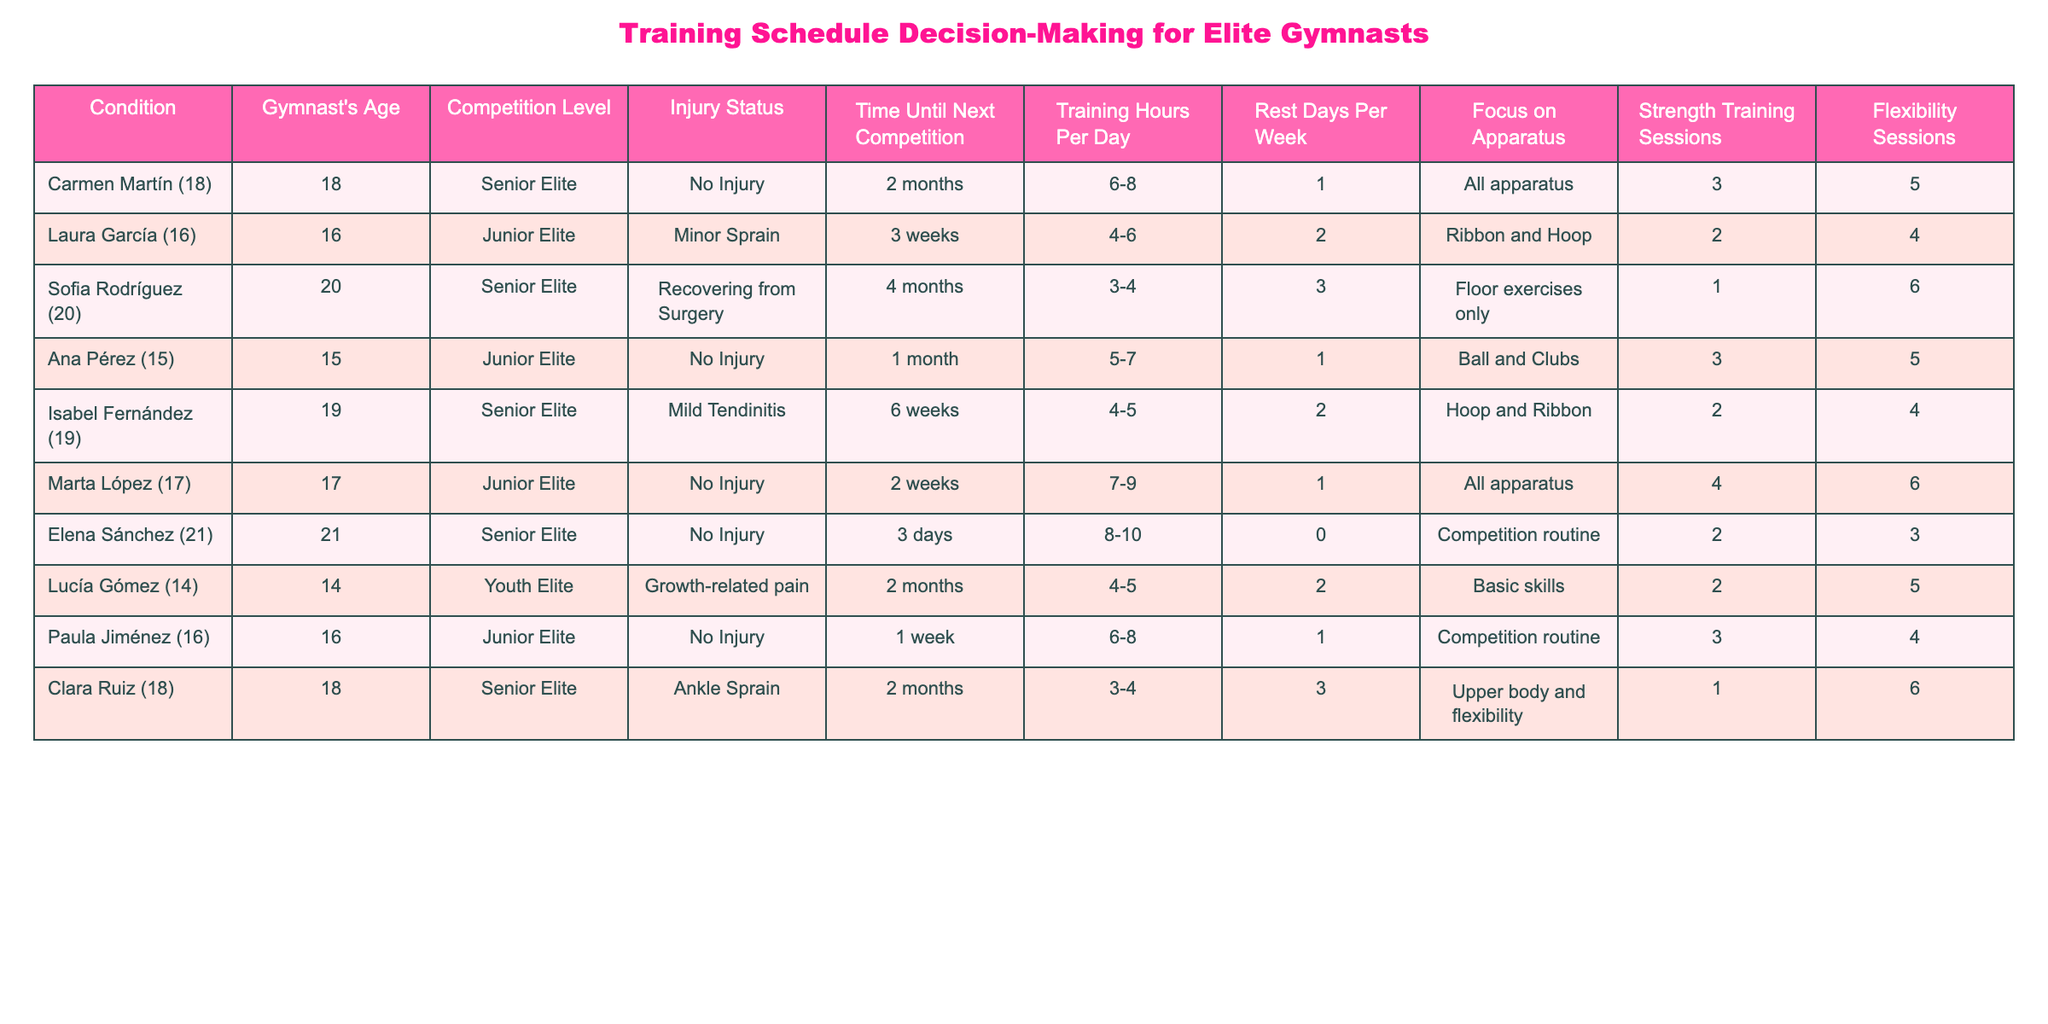What is the age of Marta López? From the table, the row corresponding to Marta López lists her age as 17 years old.
Answer: 17 Which gymnast has the highest number of training hours per day? The table indicates that Elena Sánchez has the highest training hours per day, with a range of 8-10 hours.
Answer: Elena Sánchez How many gymnasts are currently recovering from an injury? By inspecting the injury status column, we can see that three gymnasts are listed as recovering from an injury: Laura García, Sofia Rodríguez, and Clara Ruiz.
Answer: 3 What is the average number of rest days per week for Junior Elite gymnasts? The Junior Elite gymnasts are Laura García (2), Ana Pérez (1), Marta López (1), and Paula Jiménez (1). Summing these values gives 2 + 1 + 1 + 1 = 5, and dividing by 4 we find the average is 5/4 = 1.25.
Answer: 1.25 Is there a gymnast with a focus specifically on "Floor exercises only"? By checking the focus on apparatus column, we see that only Sofia Rodríguez is focused exclusively on floor exercises.
Answer: Yes What is the total number of strength training sessions for Senior Elite gymnasts? The table shows that Carmen Martín has 3, Isabel Fernández has 2, Sofia Rodríguez has 1, Clara Ruiz has 1, and Elena Sánchez has 2. Adding these gives 3 + 2 + 1 + 1 + 2 = 9 sessions in total.
Answer: 9 How long until the next competition for the gymnast with the least time remaining? Looking through the time until the next competition column, we see that Elena Sánchez has only 3 days until her next competition, which is the least amount of time compared to others.
Answer: 3 days What is the difference in training hours per day between the youngest and oldest gymnasts? The youngest gymnast is Lucía Gómez with 4-5 hours and the oldest is Sofia Rodríguez with 3-4 hours. Taking the average (4.5 for Lucía and 3.5 for Sofia) gives a difference of 4.5 - 3.5 = 1 hour.
Answer: 1 hour 